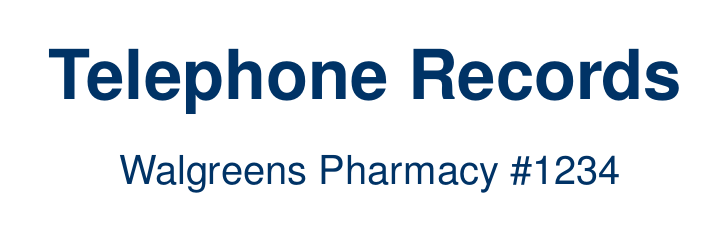what is the date of the first call? The first call in the log is dated May 10, 2023.
Answer: May 10, 2023 who did John Smith speak to during the second call? In the second call, John Smith spoke to Michael Rodriguez.
Answer: Michael Rodriguez what was discussed in the third call? The third call involved discussing a recall of Losartan and requesting information on substitutes.
Answer: Recall of Losartan how long did the call with David Thompson last? The duration of the call with David Thompson was 10 minutes.
Answer: 10 minutes what medication was ordered in the fourth call? In the fourth call, additional COVID-19 vaccines were ordered.
Answer: COVID-19 vaccines how many calls were made on May 10, 2023? Two calls were made on May 10, 2023 according to the log.
Answer: Two calls which supplier was contacted about controlled substances? Michael Rodriguez from McKesson Corporation was contacted about controlled substances.
Answer: McKesson Corporation what is the total duration of all phone calls in the log? The total duration is calculated by adding the duration of each call, which totals to 45 minutes.
Answer: 45 minutes what was the reason for requesting expedited delivery in the first call? The reason for requesting expedited delivery was due to an unexpected shortage of Atorvastatin.
Answer: Unexpected shortage who discussed the storage requirements for COVID-19 vaccines? John Smith discussed the storage requirements for COVID-19 vaccines.
Answer: John Smith 